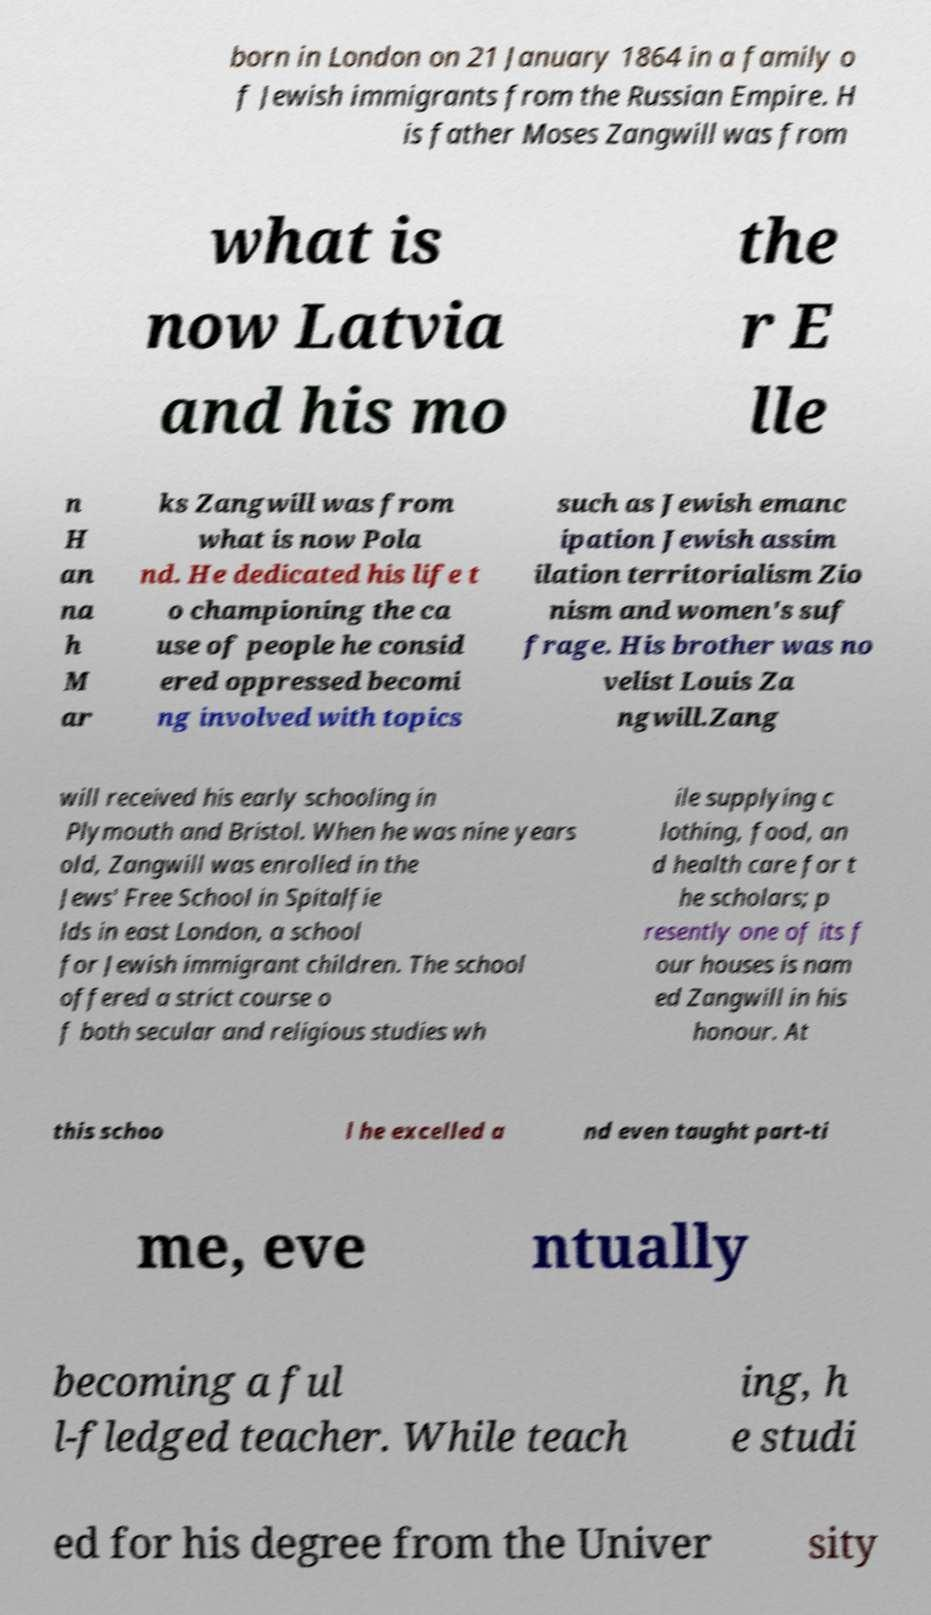Can you accurately transcribe the text from the provided image for me? born in London on 21 January 1864 in a family o f Jewish immigrants from the Russian Empire. H is father Moses Zangwill was from what is now Latvia and his mo the r E lle n H an na h M ar ks Zangwill was from what is now Pola nd. He dedicated his life t o championing the ca use of people he consid ered oppressed becomi ng involved with topics such as Jewish emanc ipation Jewish assim ilation territorialism Zio nism and women's suf frage. His brother was no velist Louis Za ngwill.Zang will received his early schooling in Plymouth and Bristol. When he was nine years old, Zangwill was enrolled in the Jews' Free School in Spitalfie lds in east London, a school for Jewish immigrant children. The school offered a strict course o f both secular and religious studies wh ile supplying c lothing, food, an d health care for t he scholars; p resently one of its f our houses is nam ed Zangwill in his honour. At this schoo l he excelled a nd even taught part-ti me, eve ntually becoming a ful l-fledged teacher. While teach ing, h e studi ed for his degree from the Univer sity 